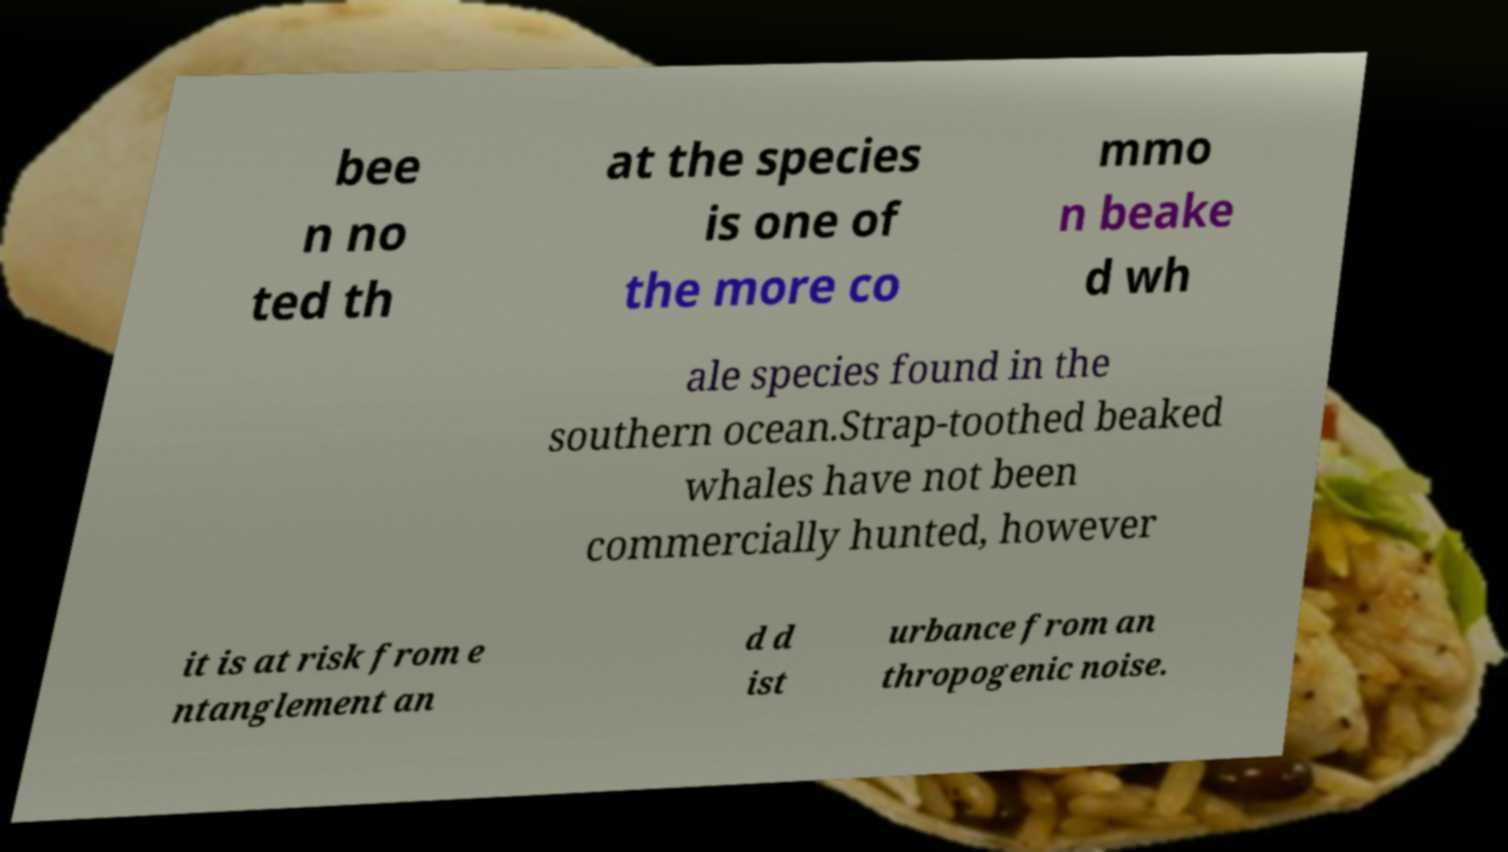I need the written content from this picture converted into text. Can you do that? bee n no ted th at the species is one of the more co mmo n beake d wh ale species found in the southern ocean.Strap-toothed beaked whales have not been commercially hunted, however it is at risk from e ntanglement an d d ist urbance from an thropogenic noise. 